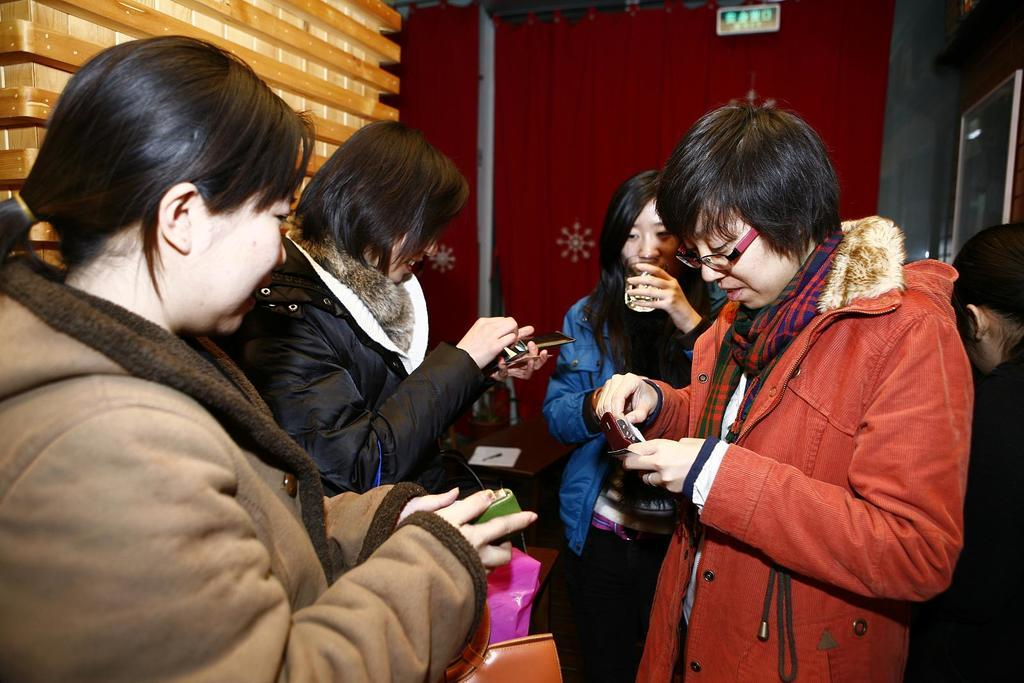How many people are present in the image? There are people in the image, but the exact number is not specified. What are the people holding in the image? The people are holding objects, but the specific objects are not described. What can be seen in the background of the image? In the background of the image, there is a board, a wall, a wooden object, a glass object, and a curtain. Can you describe the wooden object in the background? The wooden object in the background is not described in detail, so it cannot be described further. What type of glass object is present in the background? The type of glass object in the background is not specified, so it cannot be described further. How many jellyfish are swimming in the glass object in the background? There are no jellyfish present in the image, and therefore none can be seen swimming in the glass object in the background. 